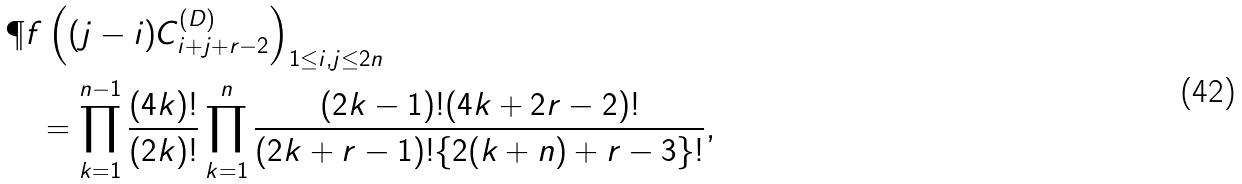Convert formula to latex. <formula><loc_0><loc_0><loc_500><loc_500>& \P f \left ( ( j - i ) C ^ { ( D ) } _ { i + j + r - 2 } \right ) _ { 1 \leq i , j \leq 2 n } \\ & \quad = \prod _ { k = 1 } ^ { n - 1 } \frac { ( 4 k ) ! } { ( 2 k ) ! } \prod _ { k = 1 } ^ { n } \frac { ( 2 k - 1 ) ! ( 4 k + 2 r - 2 ) ! } { ( 2 k + r - 1 ) ! \{ 2 ( k + n ) + r - 3 \} ! } ,</formula> 